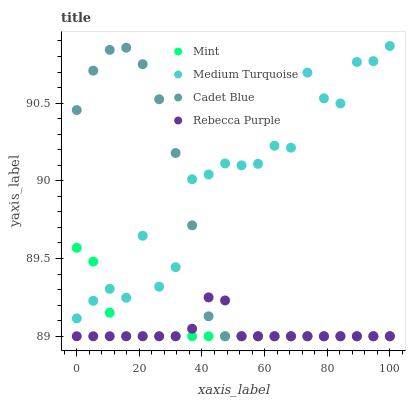Does Rebecca Purple have the minimum area under the curve?
Answer yes or no. Yes. Does Medium Turquoise have the maximum area under the curve?
Answer yes or no. Yes. Does Mint have the minimum area under the curve?
Answer yes or no. No. Does Mint have the maximum area under the curve?
Answer yes or no. No. Is Mint the smoothest?
Answer yes or no. Yes. Is Medium Turquoise the roughest?
Answer yes or no. Yes. Is Rebecca Purple the smoothest?
Answer yes or no. No. Is Rebecca Purple the roughest?
Answer yes or no. No. Does Cadet Blue have the lowest value?
Answer yes or no. Yes. Does Medium Turquoise have the lowest value?
Answer yes or no. No. Does Medium Turquoise have the highest value?
Answer yes or no. Yes. Does Mint have the highest value?
Answer yes or no. No. Is Rebecca Purple less than Medium Turquoise?
Answer yes or no. Yes. Is Medium Turquoise greater than Rebecca Purple?
Answer yes or no. Yes. Does Rebecca Purple intersect Cadet Blue?
Answer yes or no. Yes. Is Rebecca Purple less than Cadet Blue?
Answer yes or no. No. Is Rebecca Purple greater than Cadet Blue?
Answer yes or no. No. Does Rebecca Purple intersect Medium Turquoise?
Answer yes or no. No. 